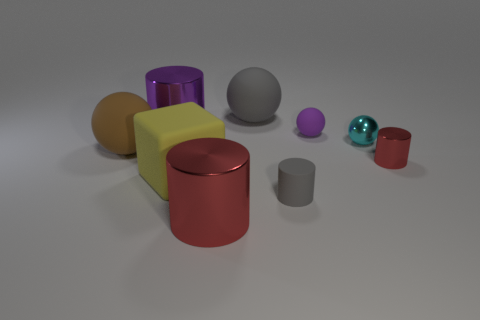Is the material of the cylinder that is left of the big red shiny cylinder the same as the small gray object?
Your response must be concise. No. What material is the small red cylinder?
Provide a succinct answer. Metal. What is the size of the shiny thing left of the large cube?
Offer a very short reply. Large. Is there any other thing that has the same color as the matte cylinder?
Keep it short and to the point. Yes. Is there a big brown sphere that is in front of the matte sphere that is left of the large thing that is right of the large red shiny cylinder?
Your answer should be compact. No. Does the large matte sphere behind the brown object have the same color as the small matte ball?
Offer a very short reply. No. How many cylinders are purple metal objects or purple objects?
Make the answer very short. 1. What is the shape of the shiny thing in front of the red shiny cylinder that is right of the small purple matte ball?
Offer a terse response. Cylinder. What size is the red metal object that is behind the red object that is on the left side of the red cylinder that is right of the tiny gray rubber cylinder?
Give a very brief answer. Small. Is the size of the gray sphere the same as the purple metal cylinder?
Ensure brevity in your answer.  Yes. 